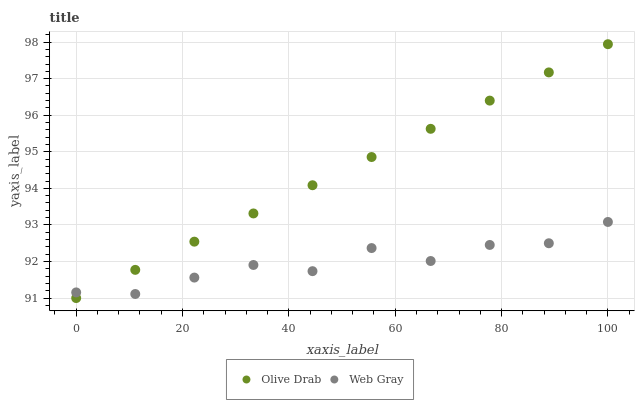Does Web Gray have the minimum area under the curve?
Answer yes or no. Yes. Does Olive Drab have the maximum area under the curve?
Answer yes or no. Yes. Does Olive Drab have the minimum area under the curve?
Answer yes or no. No. Is Olive Drab the smoothest?
Answer yes or no. Yes. Is Web Gray the roughest?
Answer yes or no. Yes. Is Olive Drab the roughest?
Answer yes or no. No. Does Olive Drab have the lowest value?
Answer yes or no. Yes. Does Olive Drab have the highest value?
Answer yes or no. Yes. Does Olive Drab intersect Web Gray?
Answer yes or no. Yes. Is Olive Drab less than Web Gray?
Answer yes or no. No. Is Olive Drab greater than Web Gray?
Answer yes or no. No. 